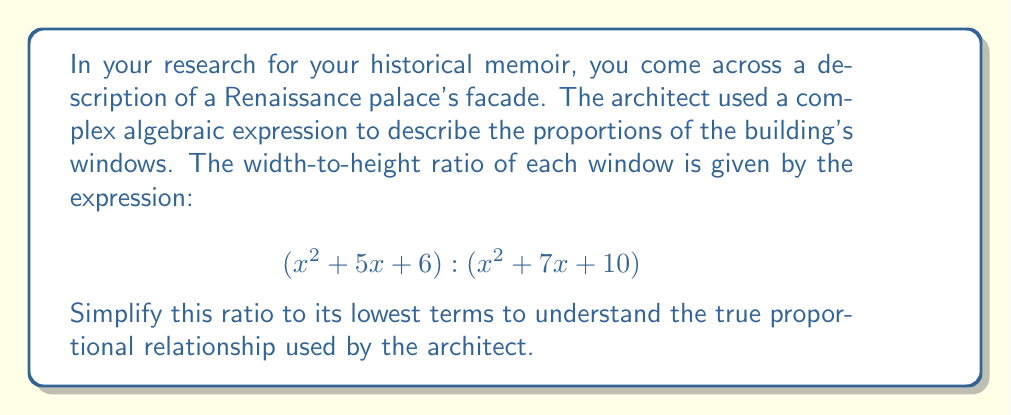Provide a solution to this math problem. To simplify this ratio, we need to factor both the numerator and denominator expressions and cancel any common factors.

1. Factor the numerator:
   $x^2 + 5x + 6$
   This is a quadratic expression. We need to find two numbers that multiply to give 6 and add up to 5.
   $(x + 2)(x + 3)$

2. Factor the denominator:
   $x^2 + 7x + 10$
   Again, we need to find two numbers that multiply to give 10 and add up to 7.
   $(x + 2)(x + 5)$

3. Now our ratio looks like this:
   $\frac{(x + 2)(x + 3)}{(x + 2)(x + 5)}$

4. We can cancel the common factor $(x + 2)$ from both the numerator and denominator:
   $\frac{(x + 3)}{(x + 5)}$

5. This fraction cannot be simplified further as there are no more common factors.

Therefore, the simplified ratio is $(x + 3) : (x + 5)$.
Answer: $(x + 3) : (x + 5)$ 